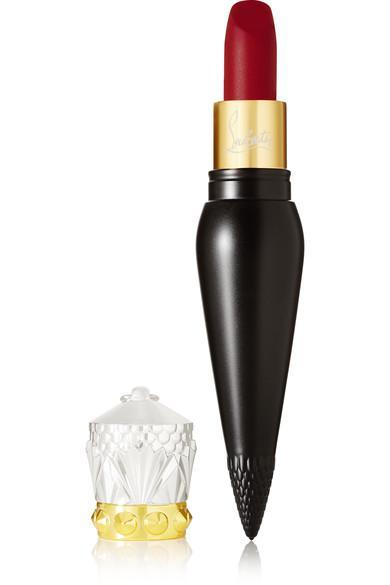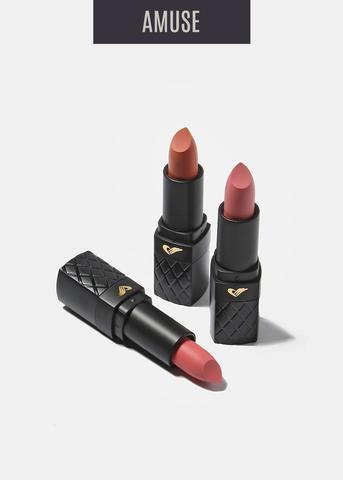The first image is the image on the left, the second image is the image on the right. Assess this claim about the two images: "Lipstick in a black and gold vial shaped tube is balanced upright on the tip and has a cap that resembles a crown set down next to it.". Correct or not? Answer yes or no. Yes. The first image is the image on the left, the second image is the image on the right. Analyze the images presented: Is the assertion "There are three lipsticks with black cases in at least one image." valid? Answer yes or no. Yes. 